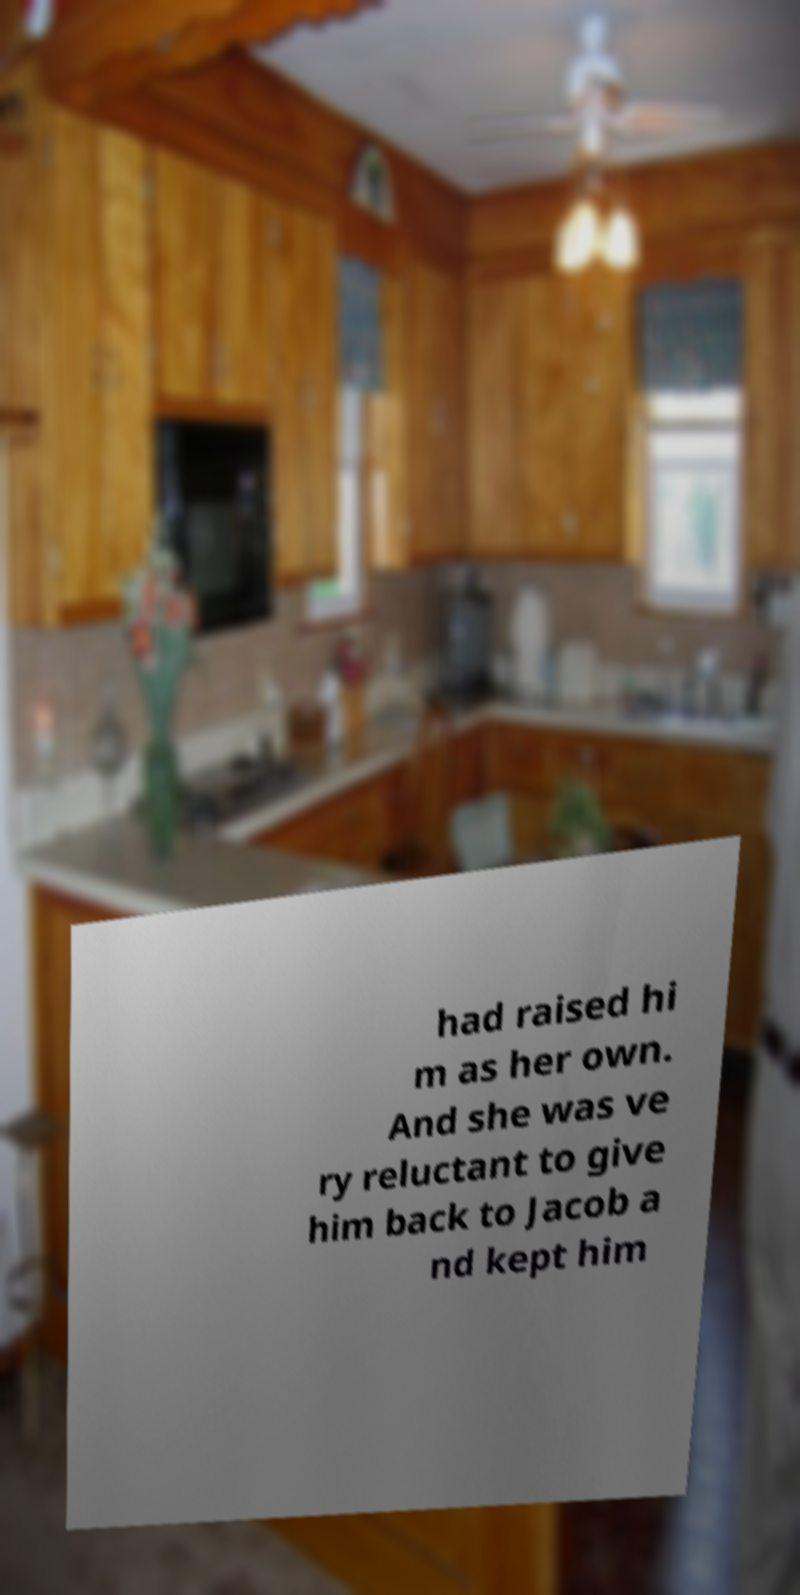Please identify and transcribe the text found in this image. had raised hi m as her own. And she was ve ry reluctant to give him back to Jacob a nd kept him 